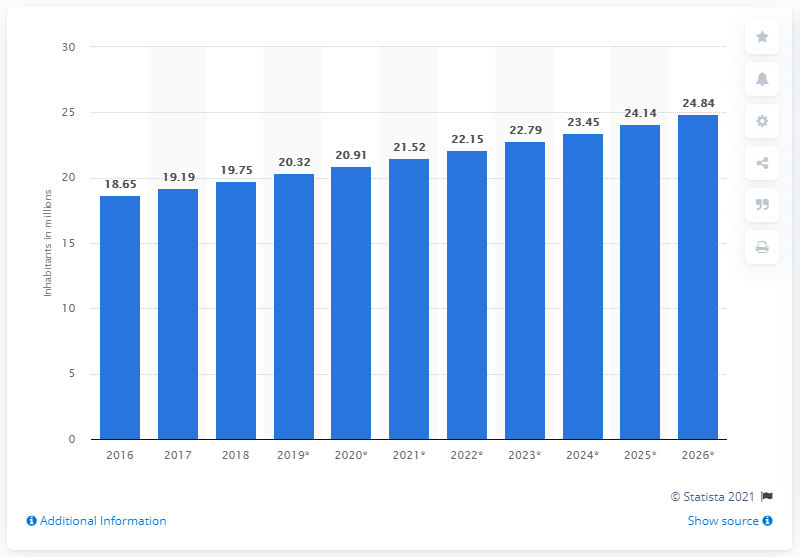Indicate a few pertinent items in this graphic. In 2018, the population of Burkina Faso was approximately 19.75 million. In 2016, the population of Burkina Faso began to increase. 